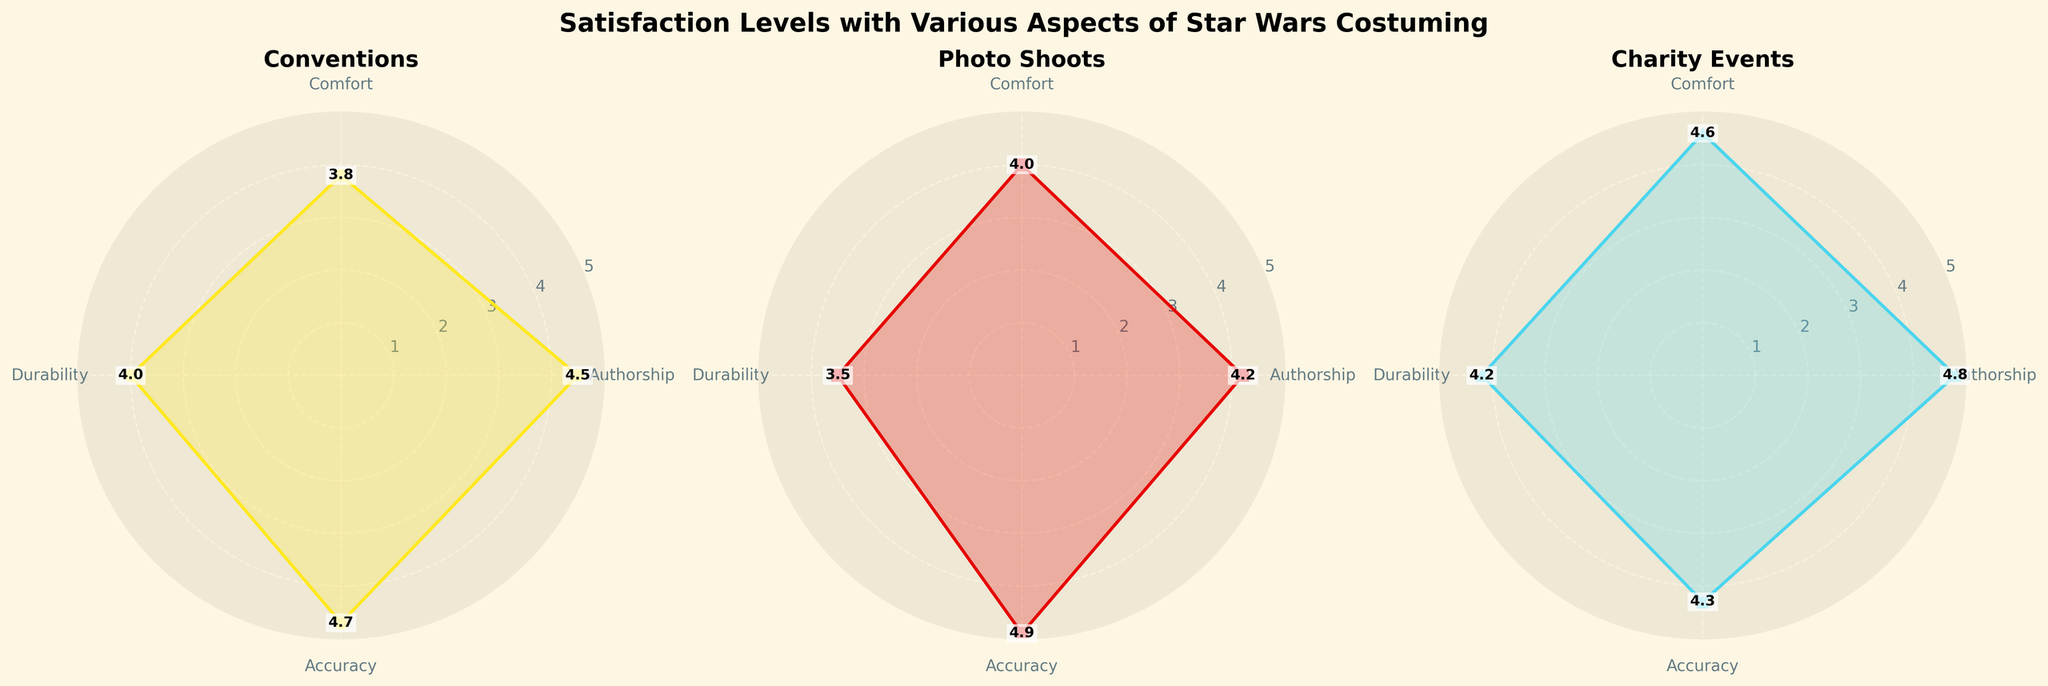What is the average satisfaction rating for Comfort in all event types? The Comfort ratings are 3.8 for Conventions, 4.0 for Photo Shoots, and 4.6 for Charity Events. Add these and divide by the number of events: (3.8 + 4.0 + 4.6) / 3 = 4.13.
Answer: 4.13 Which event type has the highest accuracy rating? The accuracy ratings are 4.7 for Conventions, 4.9 for Photo Shoots, and 4.3 for Charity Events. Among these, 4.9 is the highest, corresponding to Photo Shoots.
Answer: Photo Shoots Which costume aspect has the lowest satisfaction rating for Photo Shoots? The ratings for Photo Shoots are 4.2 for Authorship, 4.0 for Comfort, 3.5 for Durability, and 4.9 for Accuracy. The lowest value is 3.5, corresponding to Durability.
Answer: Durability Compare the Authorship satisfaction rating between Charity Events and Conventions. The Authorship rating is 4.8 for Charity Events and 4.5 for Conventions. 4.8 is greater than 4.5.
Answer: Charity Events What is the overall trend in satisfaction ratings for Durability across the event types? The Durability ratings are 4.0 for Conventions, 3.5 for Photo Shoots, and 4.2 for Charity Events. The trend shows a dip in satisfaction for Photo Shoots compared to Conventions and Charity Events.
Answer: Dip at Photo Shoots What is the difference in Comfort satisfaction between Charity Events and Conventions? The Comfort rating for Charity Events is 4.6, and for Conventions, it is 3.8. The difference is 4.6 - 3.8 = 0.8.
Answer: 0.8 Which costume aspect shows the highest variability in satisfaction ratings across all event types? For Authorship, the ratings are 4.5, 4.2, and 4.8. For Comfort, the ratings are 3.8, 4.0, and 4.6. For Durability, the ratings are 4.0, 3.5, and 4.2. For Accuracy, the ratings are 4.7, 4.9, and 4.3. The range is calculated by max rating - min rating. Durability (0.7), Comfort (0.8), Accuracy (0.6), Authorship (0.6). Comfort has the highest variability.
Answer: Comfort What is the median satisfaction rating for Accuracy for all event types? The Accuracy ratings are 4.7, 4.9, and 4.3. When these are ordered (4.3, 4.7, 4.9), the median is 4.7 as it is the middle value.
Answer: 4.7 From which event type do we get the lowest satisfaction in any costume aspect? What is the specific value? The lowest satisfaction is found in Photo Shoots for Durability with a rating of 3.5.
Answer: Photo Shoots; 3.5 